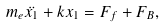<formula> <loc_0><loc_0><loc_500><loc_500>m _ { e } \ddot { x _ { 1 } } + k x _ { 1 } = F _ { f } + F _ { B } ,</formula> 